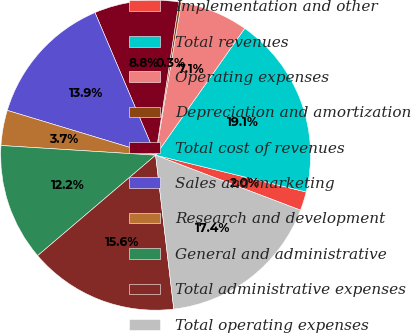Convert chart. <chart><loc_0><loc_0><loc_500><loc_500><pie_chart><fcel>Implementation and other<fcel>Total revenues<fcel>Operating expenses<fcel>Depreciation and amortization<fcel>Total cost of revenues<fcel>Sales and marketing<fcel>Research and development<fcel>General and administrative<fcel>Total administrative expenses<fcel>Total operating expenses<nl><fcel>1.96%<fcel>19.06%<fcel>7.09%<fcel>0.25%<fcel>8.8%<fcel>13.93%<fcel>3.67%<fcel>12.22%<fcel>15.64%<fcel>17.35%<nl></chart> 